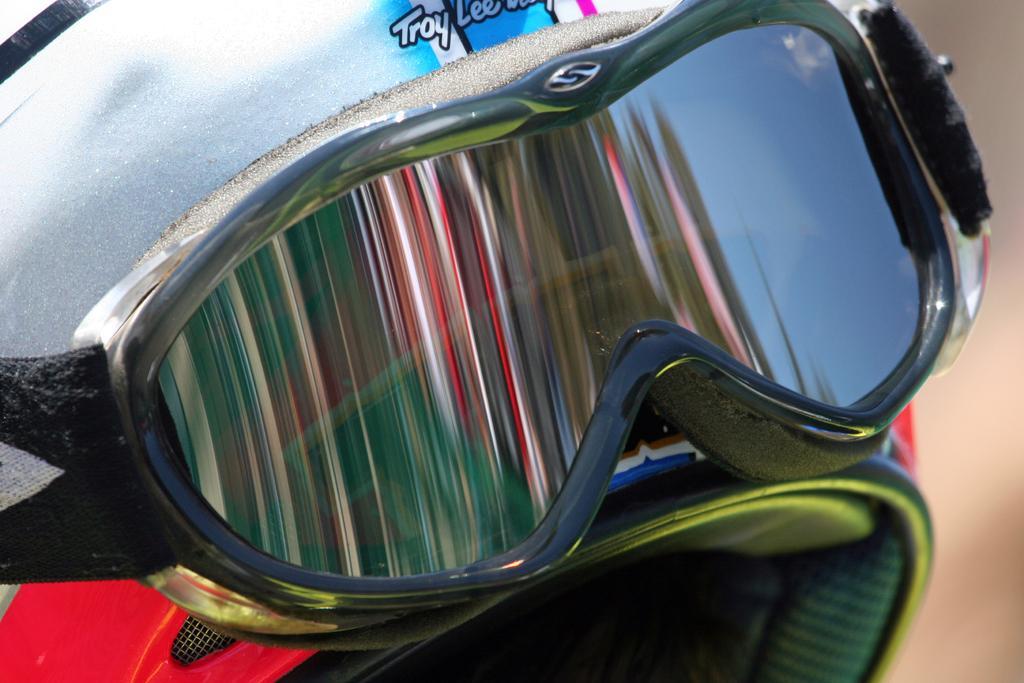Describe this image in one or two sentences. In this image there is a helmet having goggles kept on it. Background is blurry. 